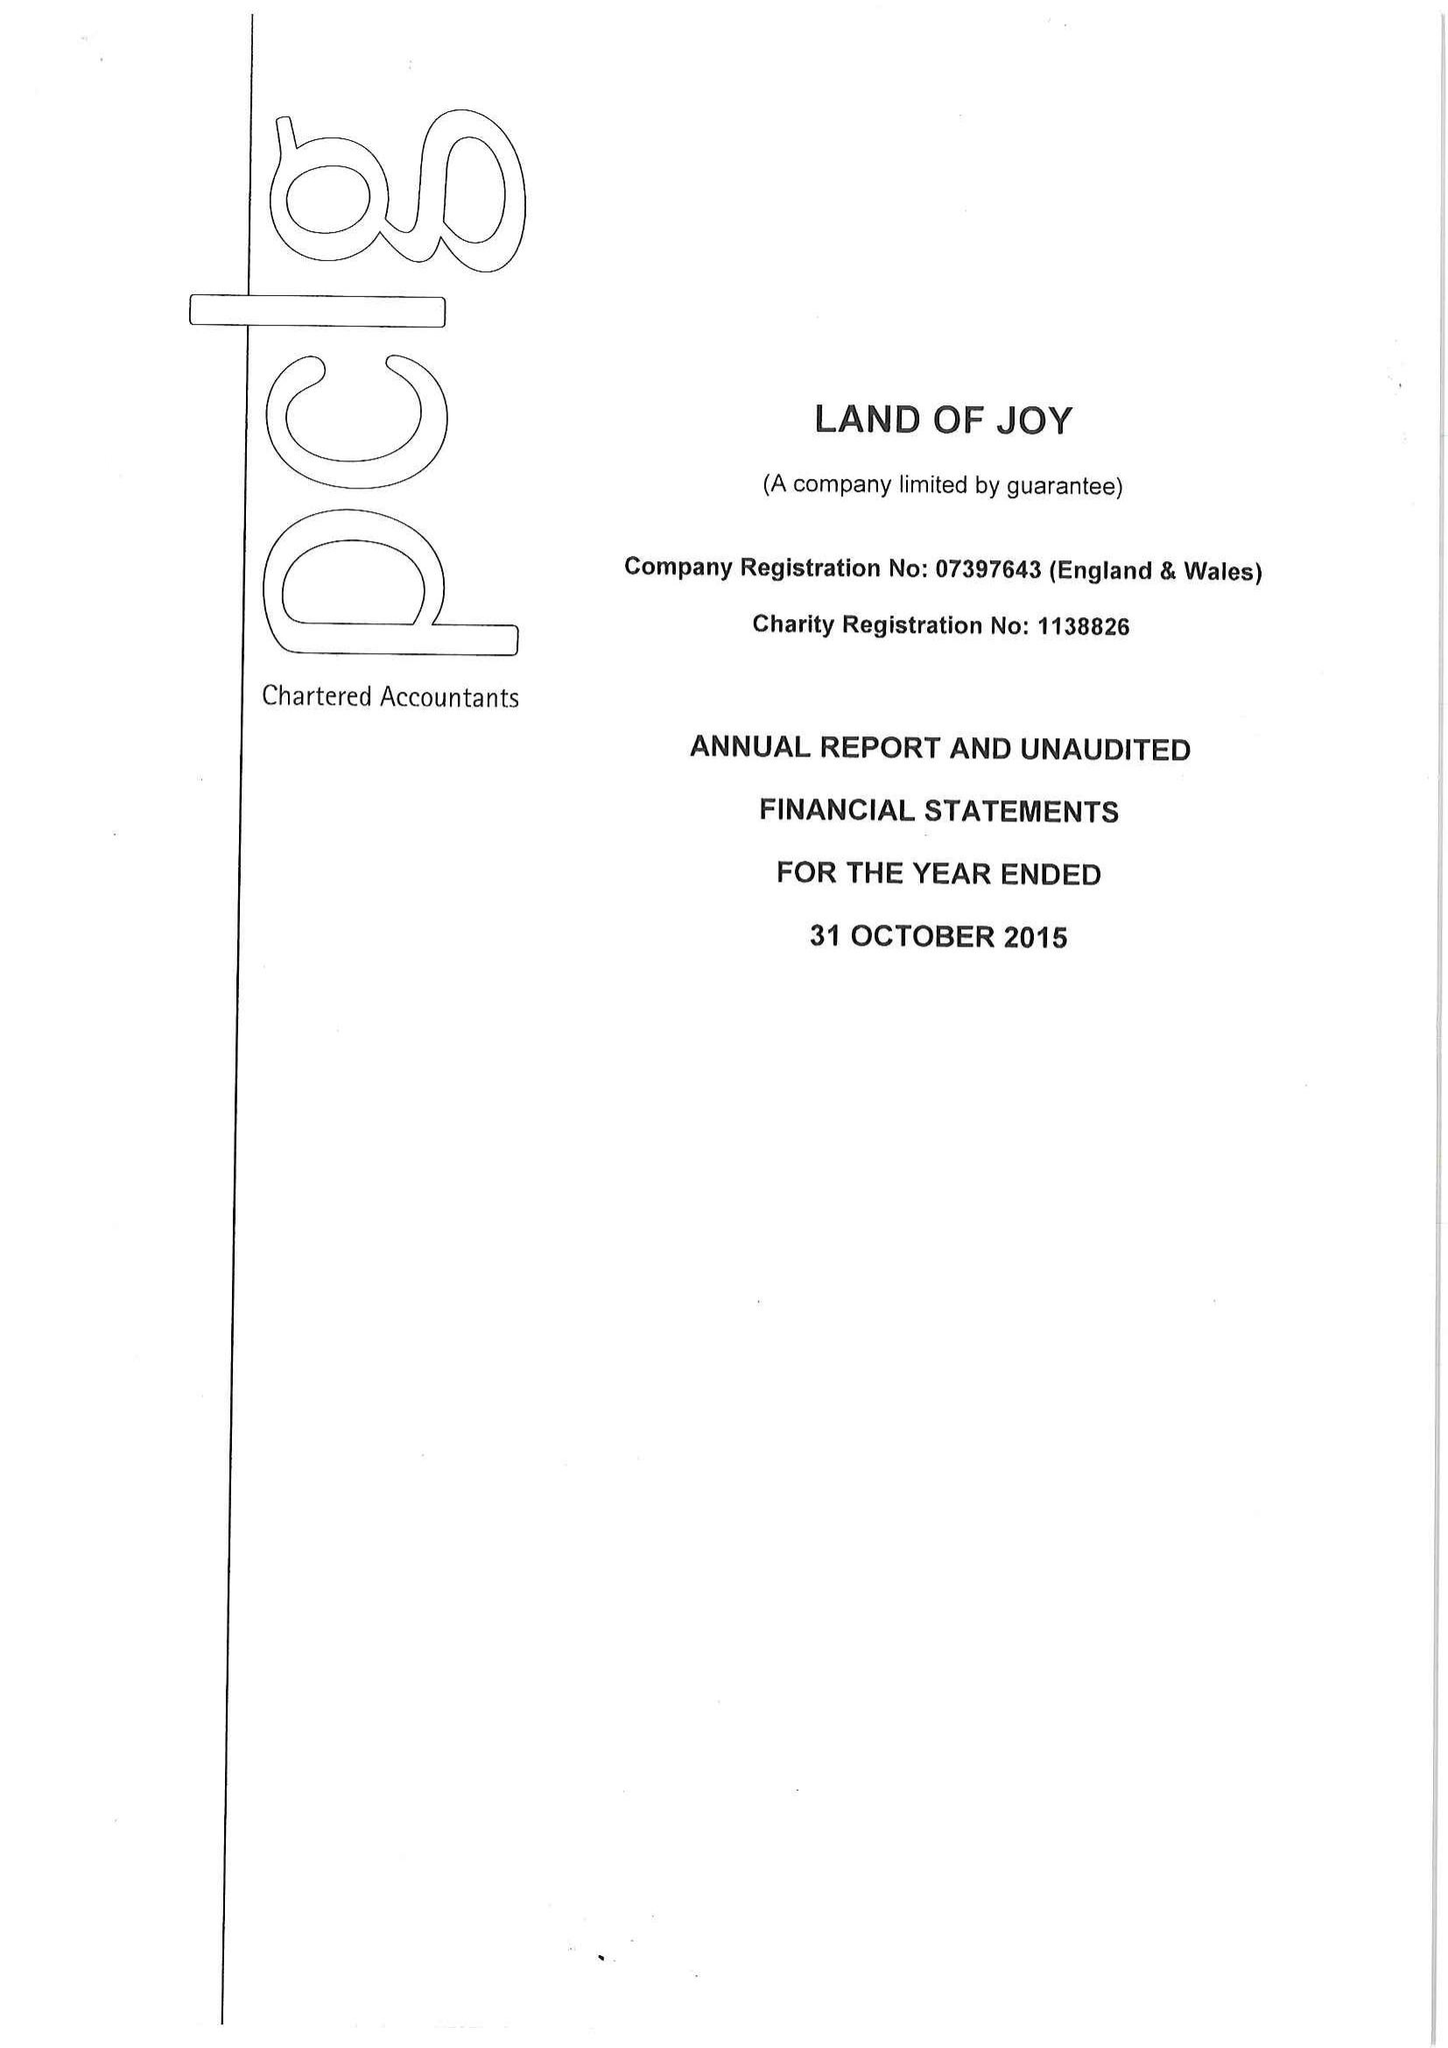What is the value for the address__post_town?
Answer the question using a single word or phrase. HEXHAM 